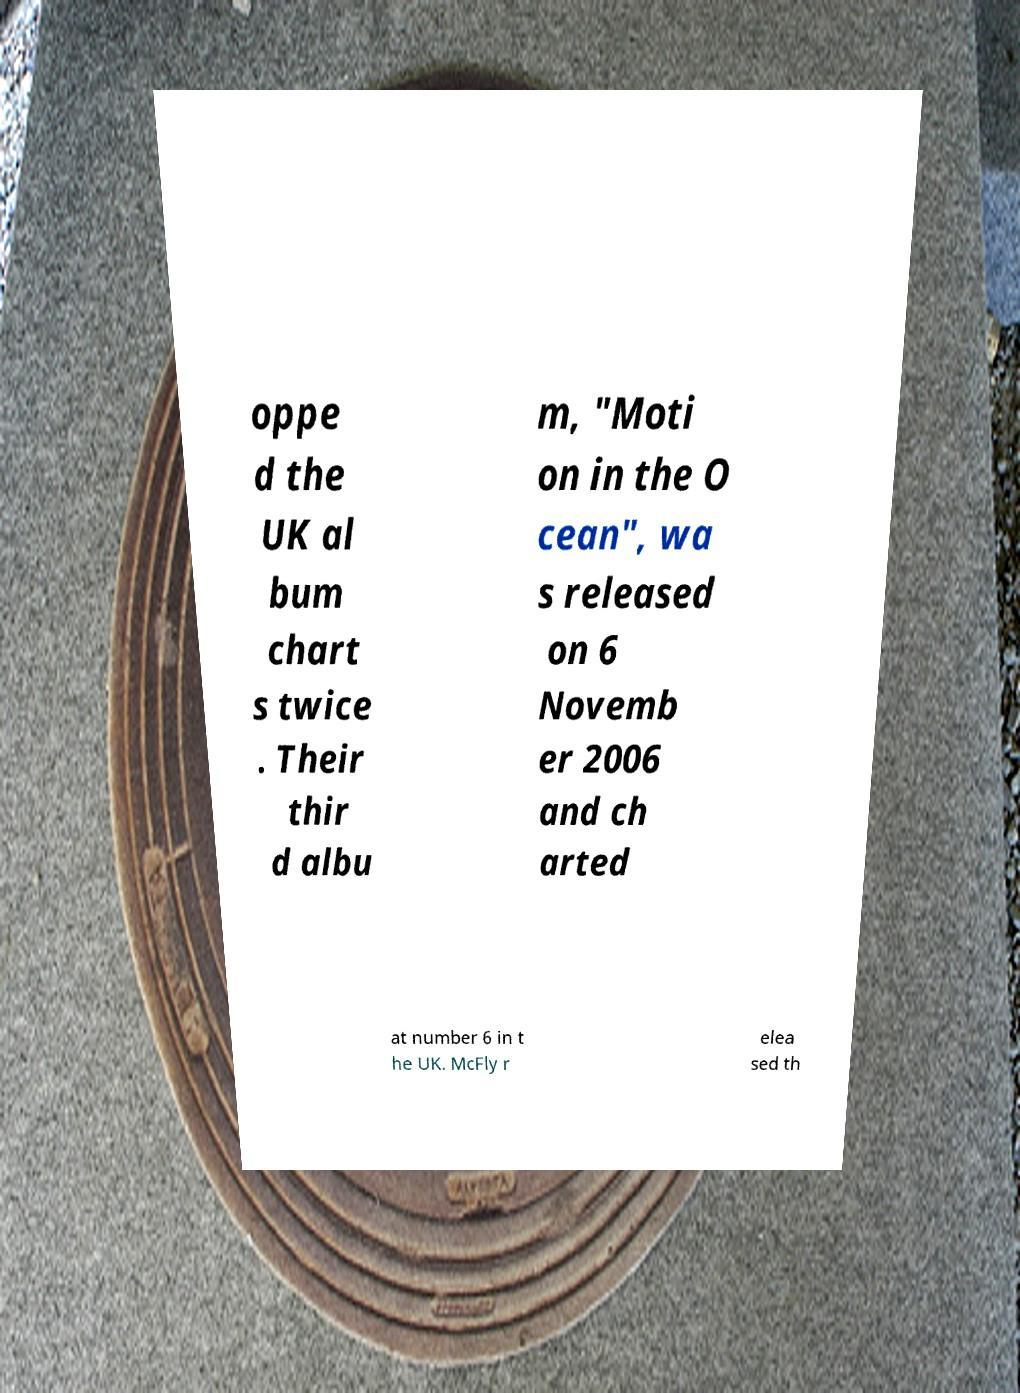Can you accurately transcribe the text from the provided image for me? oppe d the UK al bum chart s twice . Their thir d albu m, "Moti on in the O cean", wa s released on 6 Novemb er 2006 and ch arted at number 6 in t he UK. McFly r elea sed th 